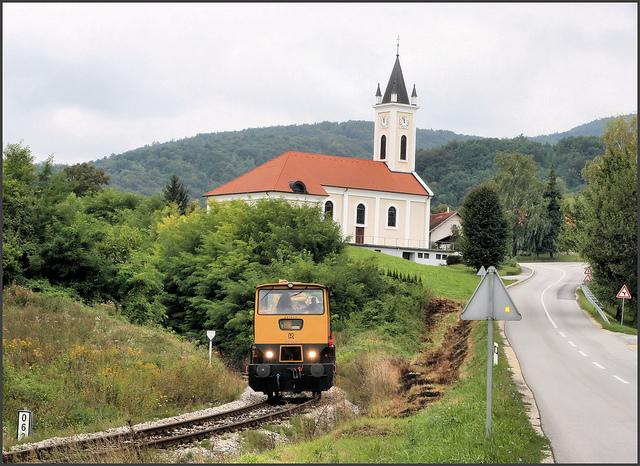What period of the day is shown here? Please explain your reasoning. almost noon. It is almost noon. 